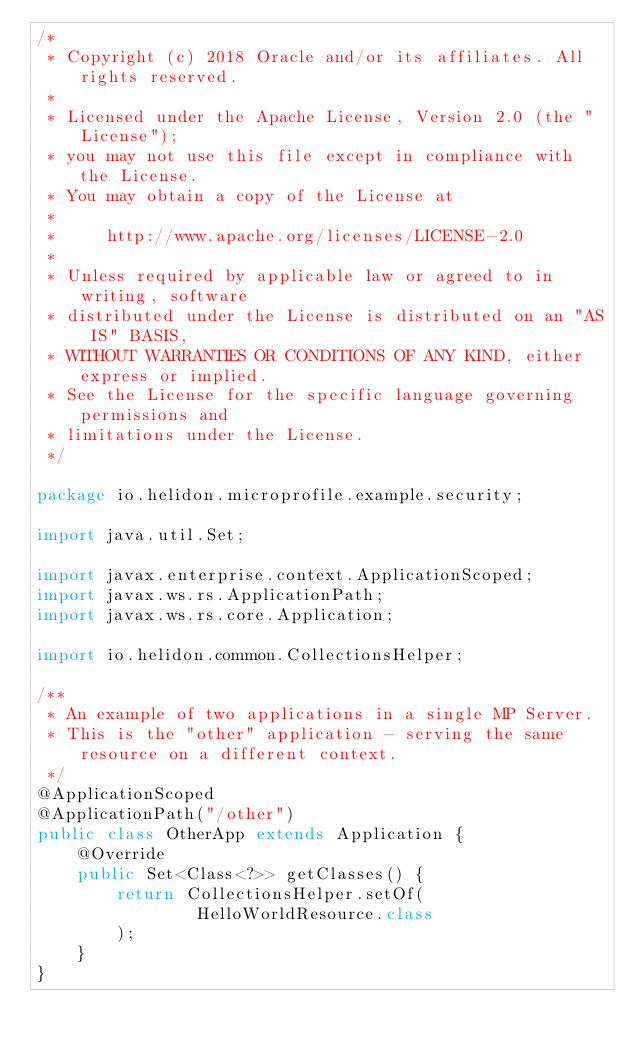Convert code to text. <code><loc_0><loc_0><loc_500><loc_500><_Java_>/*
 * Copyright (c) 2018 Oracle and/or its affiliates. All rights reserved.
 *
 * Licensed under the Apache License, Version 2.0 (the "License");
 * you may not use this file except in compliance with the License.
 * You may obtain a copy of the License at
 *
 *     http://www.apache.org/licenses/LICENSE-2.0
 *
 * Unless required by applicable law or agreed to in writing, software
 * distributed under the License is distributed on an "AS IS" BASIS,
 * WITHOUT WARRANTIES OR CONDITIONS OF ANY KIND, either express or implied.
 * See the License for the specific language governing permissions and
 * limitations under the License.
 */

package io.helidon.microprofile.example.security;

import java.util.Set;

import javax.enterprise.context.ApplicationScoped;
import javax.ws.rs.ApplicationPath;
import javax.ws.rs.core.Application;

import io.helidon.common.CollectionsHelper;

/**
 * An example of two applications in a single MP Server.
 * This is the "other" application - serving the same resource on a different context.
 */
@ApplicationScoped
@ApplicationPath("/other")
public class OtherApp extends Application {
    @Override
    public Set<Class<?>> getClasses() {
        return CollectionsHelper.setOf(
                HelloWorldResource.class
        );
    }
}
</code> 